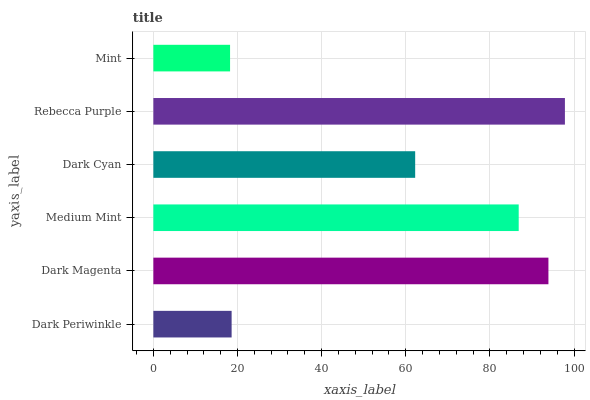Is Mint the minimum?
Answer yes or no. Yes. Is Rebecca Purple the maximum?
Answer yes or no. Yes. Is Dark Magenta the minimum?
Answer yes or no. No. Is Dark Magenta the maximum?
Answer yes or no. No. Is Dark Magenta greater than Dark Periwinkle?
Answer yes or no. Yes. Is Dark Periwinkle less than Dark Magenta?
Answer yes or no. Yes. Is Dark Periwinkle greater than Dark Magenta?
Answer yes or no. No. Is Dark Magenta less than Dark Periwinkle?
Answer yes or no. No. Is Medium Mint the high median?
Answer yes or no. Yes. Is Dark Cyan the low median?
Answer yes or no. Yes. Is Dark Cyan the high median?
Answer yes or no. No. Is Dark Magenta the low median?
Answer yes or no. No. 